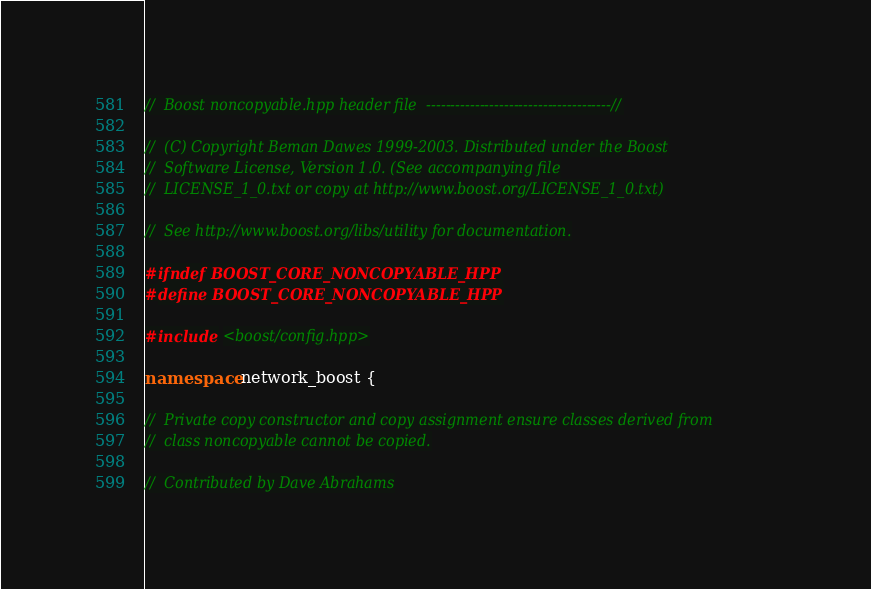<code> <loc_0><loc_0><loc_500><loc_500><_C++_>//  Boost noncopyable.hpp header file  --------------------------------------//

//  (C) Copyright Beman Dawes 1999-2003. Distributed under the Boost
//  Software License, Version 1.0. (See accompanying file
//  LICENSE_1_0.txt or copy at http://www.boost.org/LICENSE_1_0.txt)

//  See http://www.boost.org/libs/utility for documentation.

#ifndef BOOST_CORE_NONCOPYABLE_HPP
#define BOOST_CORE_NONCOPYABLE_HPP

#include <boost/config.hpp>

namespace network_boost {

//  Private copy constructor and copy assignment ensure classes derived from
//  class noncopyable cannot be copied.

//  Contributed by Dave Abrahams
</code> 